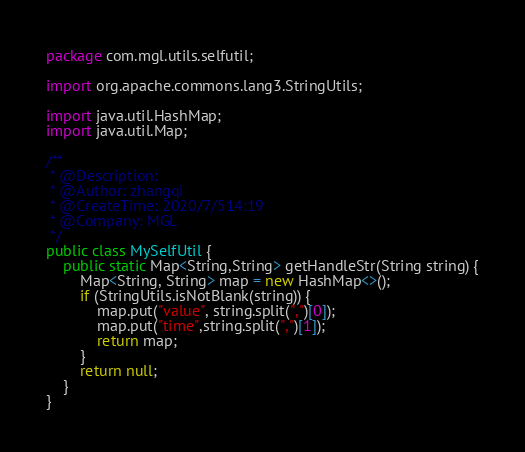Convert code to text. <code><loc_0><loc_0><loc_500><loc_500><_Java_>package com.mgl.utils.selfutil;

import org.apache.commons.lang3.StringUtils;

import java.util.HashMap;
import java.util.Map;

/**
 * @Description:
 * @Author: zhangqi
 * @CreateTime: 2020/7/514:19
 * @Company: MGL
 */
public class MySelfUtil {
    public static Map<String,String> getHandleStr(String string) {
        Map<String, String> map = new HashMap<>();
        if (StringUtils.isNotBlank(string)) {
            map.put("value", string.split(",")[0]);
            map.put("time",string.split(",")[1]);
            return map;
        }
        return null;
    }
}
</code> 